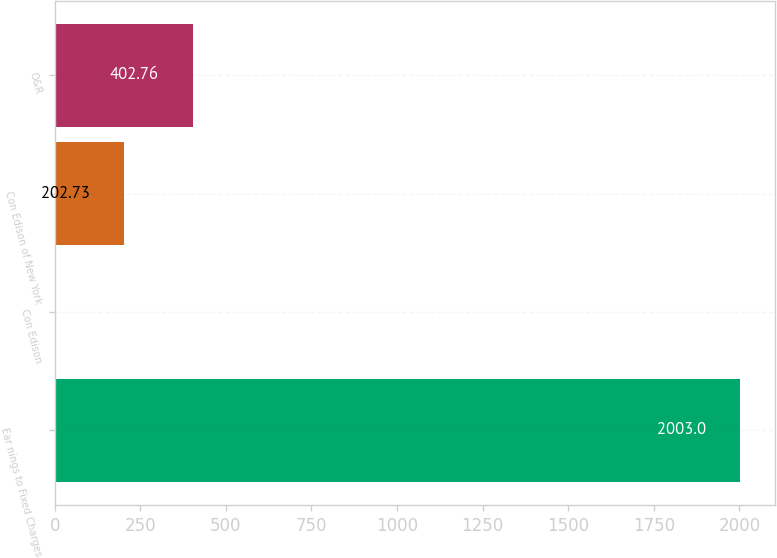Convert chart to OTSL. <chart><loc_0><loc_0><loc_500><loc_500><bar_chart><fcel>Ear nings to Fixed Charges<fcel>Con Edison<fcel>Con Edison of New York<fcel>O&R<nl><fcel>2003<fcel>2.7<fcel>202.73<fcel>402.76<nl></chart> 